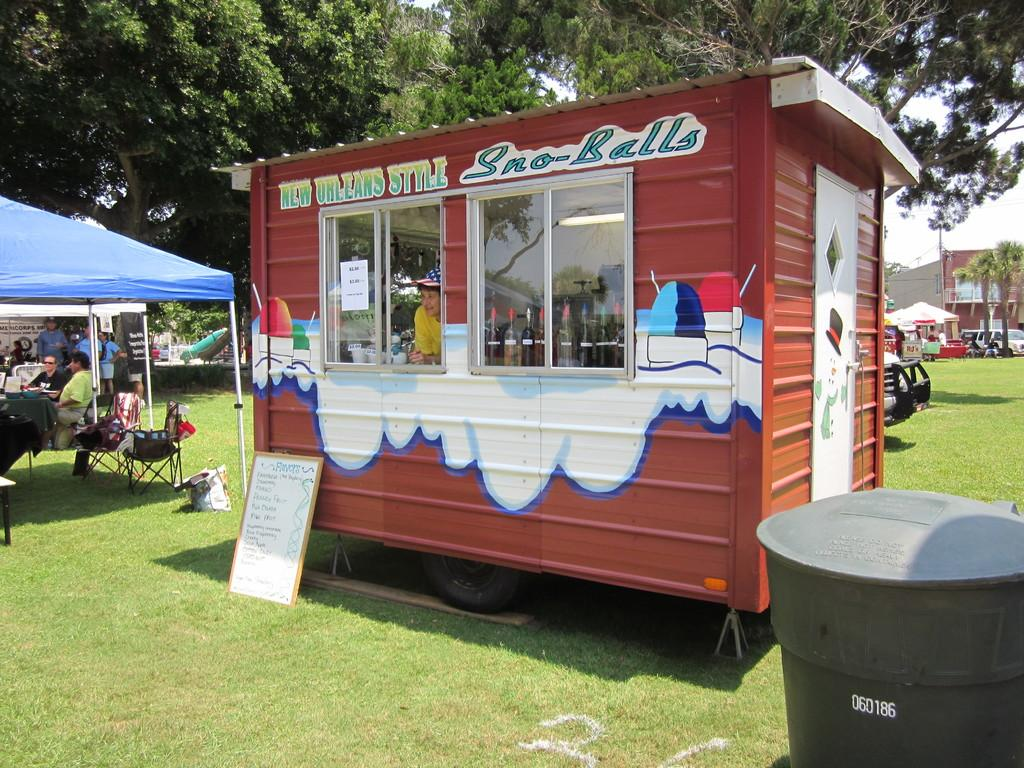<image>
Present a compact description of the photo's key features. A person selling New Orleans style Sno-Balls at an event. 